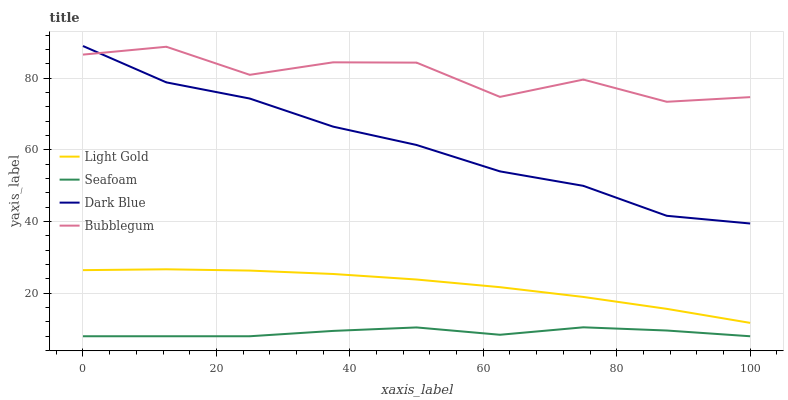Does Seafoam have the minimum area under the curve?
Answer yes or no. Yes. Does Bubblegum have the maximum area under the curve?
Answer yes or no. Yes. Does Light Gold have the minimum area under the curve?
Answer yes or no. No. Does Light Gold have the maximum area under the curve?
Answer yes or no. No. Is Light Gold the smoothest?
Answer yes or no. Yes. Is Bubblegum the roughest?
Answer yes or no. Yes. Is Seafoam the smoothest?
Answer yes or no. No. Is Seafoam the roughest?
Answer yes or no. No. Does Light Gold have the lowest value?
Answer yes or no. No. Does Dark Blue have the highest value?
Answer yes or no. Yes. Does Light Gold have the highest value?
Answer yes or no. No. Is Light Gold less than Bubblegum?
Answer yes or no. Yes. Is Light Gold greater than Seafoam?
Answer yes or no. Yes. Does Bubblegum intersect Dark Blue?
Answer yes or no. Yes. Is Bubblegum less than Dark Blue?
Answer yes or no. No. Is Bubblegum greater than Dark Blue?
Answer yes or no. No. Does Light Gold intersect Bubblegum?
Answer yes or no. No. 